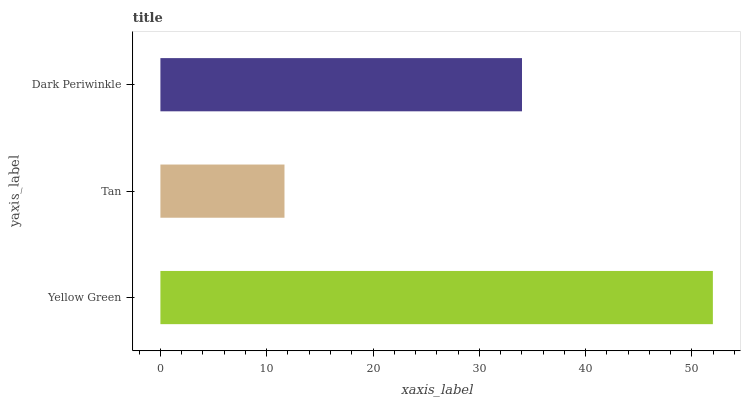Is Tan the minimum?
Answer yes or no. Yes. Is Yellow Green the maximum?
Answer yes or no. Yes. Is Dark Periwinkle the minimum?
Answer yes or no. No. Is Dark Periwinkle the maximum?
Answer yes or no. No. Is Dark Periwinkle greater than Tan?
Answer yes or no. Yes. Is Tan less than Dark Periwinkle?
Answer yes or no. Yes. Is Tan greater than Dark Periwinkle?
Answer yes or no. No. Is Dark Periwinkle less than Tan?
Answer yes or no. No. Is Dark Periwinkle the high median?
Answer yes or no. Yes. Is Dark Periwinkle the low median?
Answer yes or no. Yes. Is Yellow Green the high median?
Answer yes or no. No. Is Tan the low median?
Answer yes or no. No. 